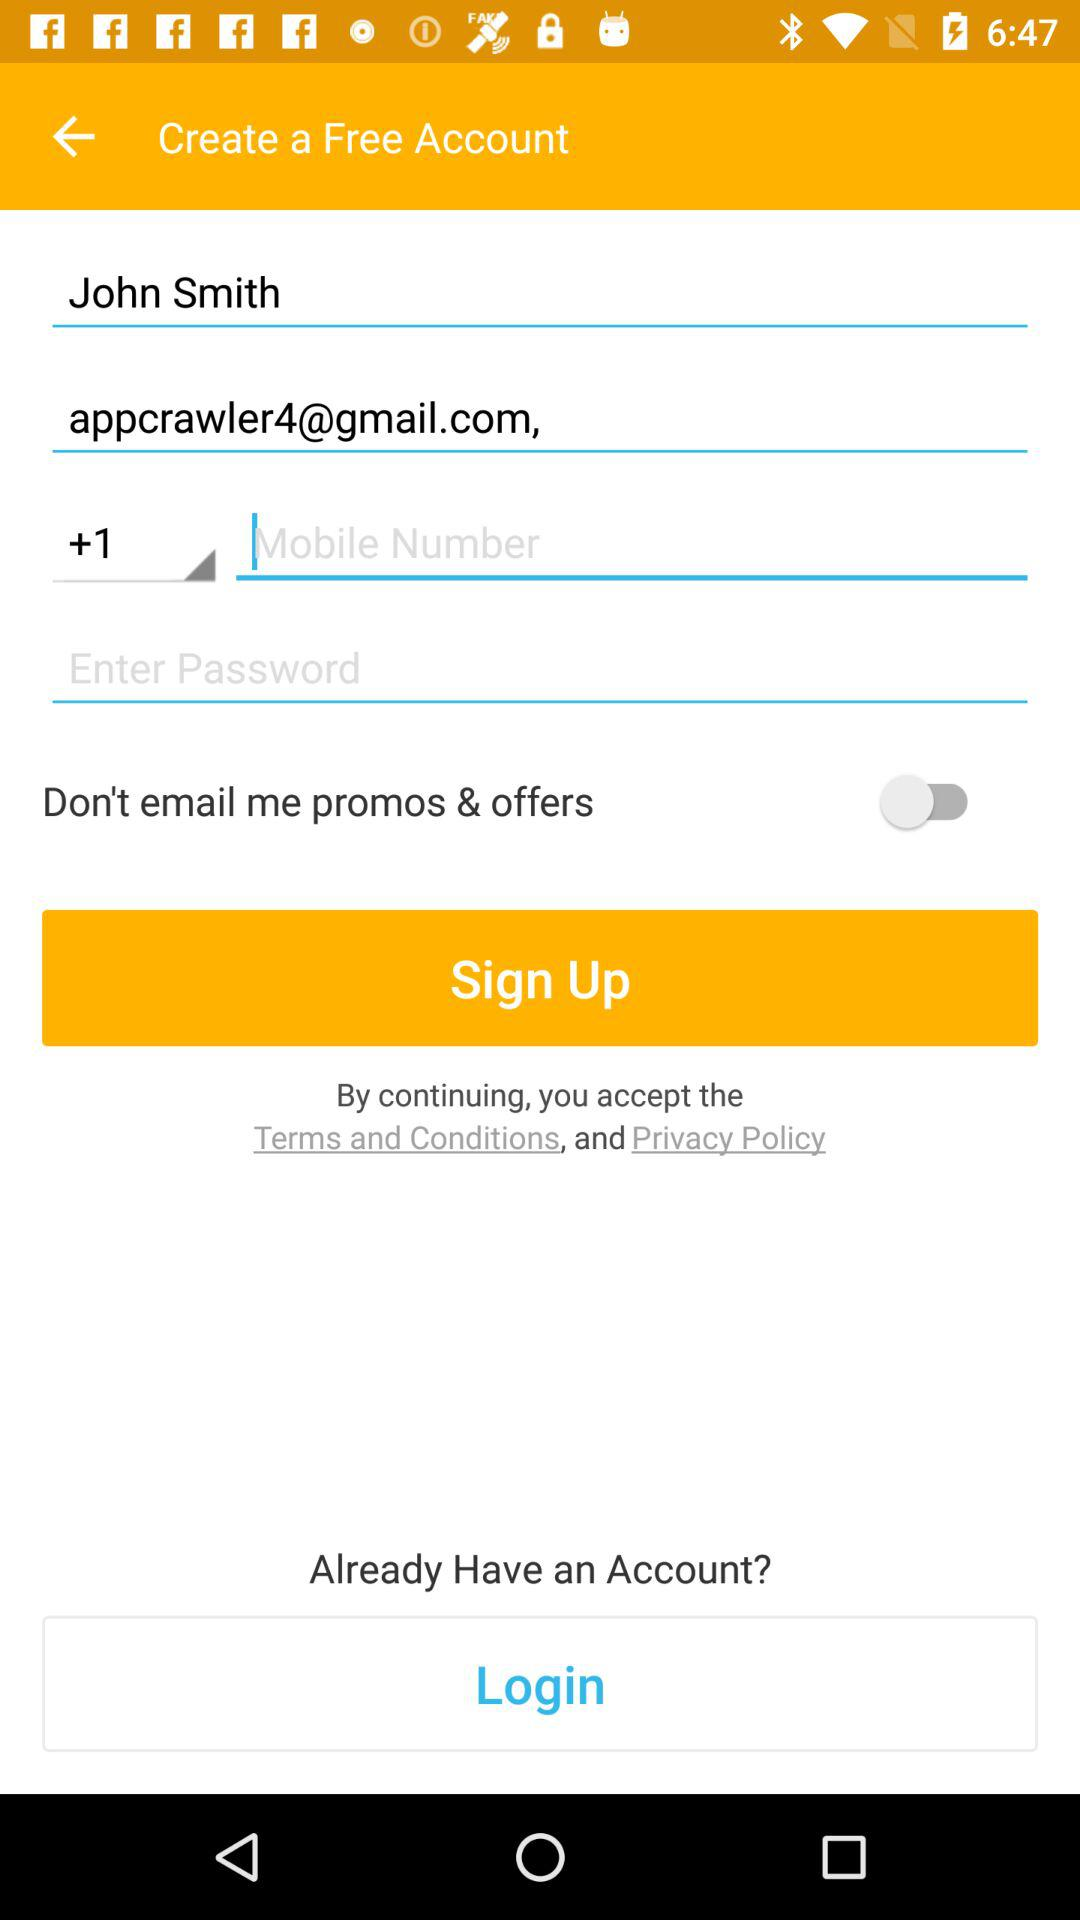What is the email address of the user? The email address of the user is appcrawler4@gmail.com. 